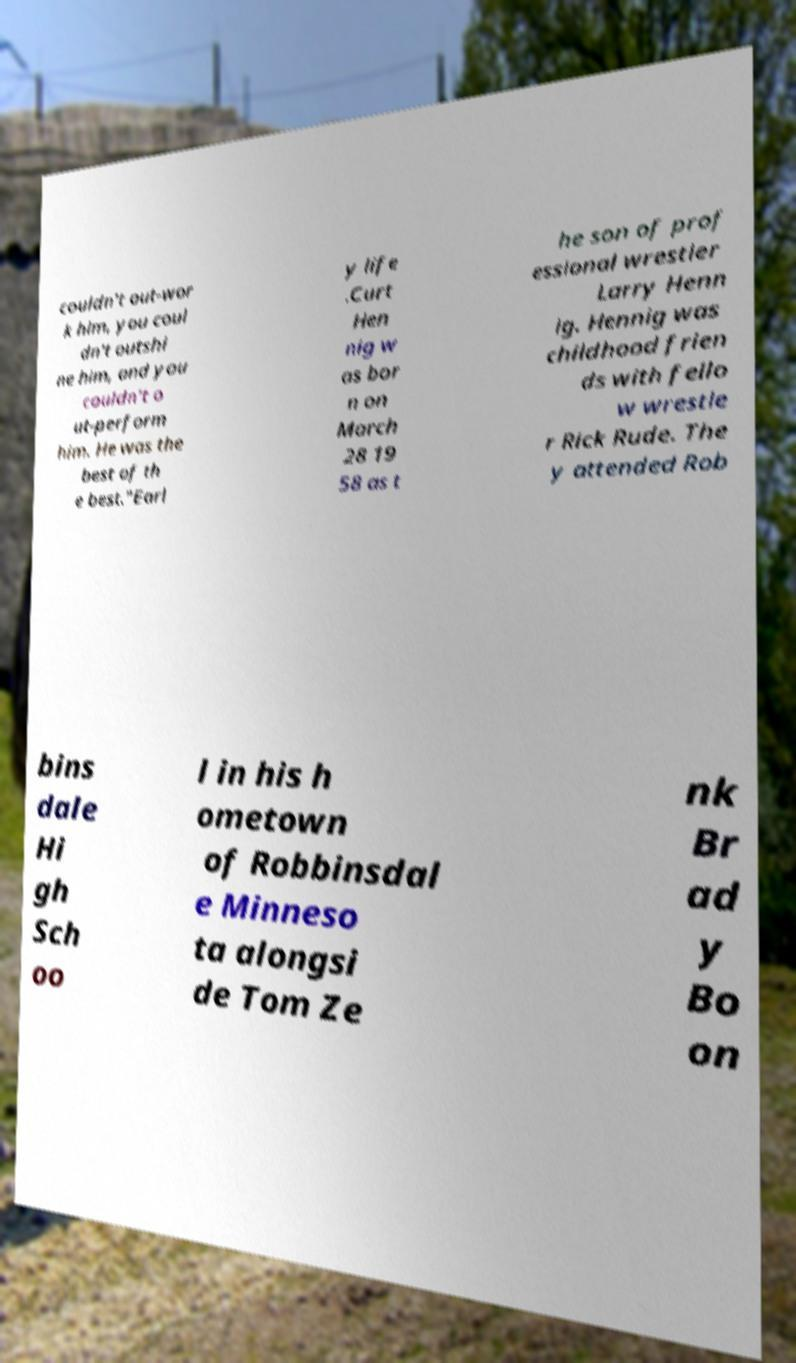I need the written content from this picture converted into text. Can you do that? couldn't out-wor k him, you coul dn't outshi ne him, and you couldn't o ut-perform him. He was the best of th e best."Earl y life .Curt Hen nig w as bor n on March 28 19 58 as t he son of prof essional wrestler Larry Henn ig. Hennig was childhood frien ds with fello w wrestle r Rick Rude. The y attended Rob bins dale Hi gh Sch oo l in his h ometown of Robbinsdal e Minneso ta alongsi de Tom Ze nk Br ad y Bo on 